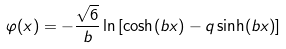<formula> <loc_0><loc_0><loc_500><loc_500>\varphi ( x ) = - \frac { \sqrt { 6 } } { b } \ln \left [ \cosh ( b x ) - q \sinh ( b x ) \right ]</formula> 